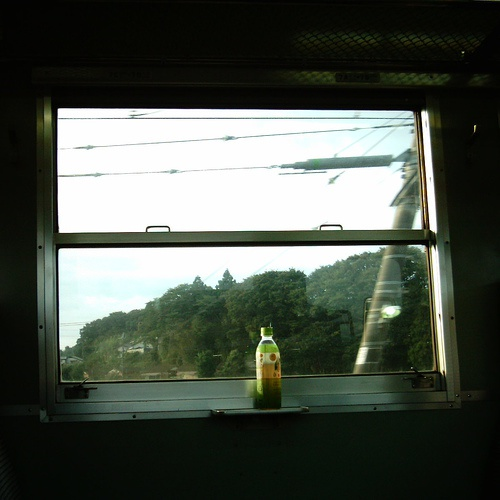Describe the objects in this image and their specific colors. I can see a bottle in black, olive, and darkgreen tones in this image. 